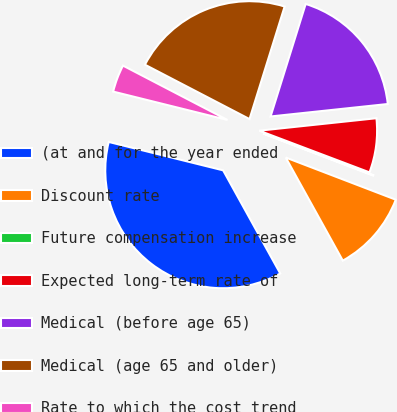<chart> <loc_0><loc_0><loc_500><loc_500><pie_chart><fcel>(at and for the year ended<fcel>Discount rate<fcel>Future compensation increase<fcel>Expected long-term rate of<fcel>Medical (before age 65)<fcel>Medical (age 65 and older)<fcel>Rate to which the cost trend<nl><fcel>36.92%<fcel>11.13%<fcel>0.07%<fcel>7.44%<fcel>18.5%<fcel>22.18%<fcel>3.76%<nl></chart> 